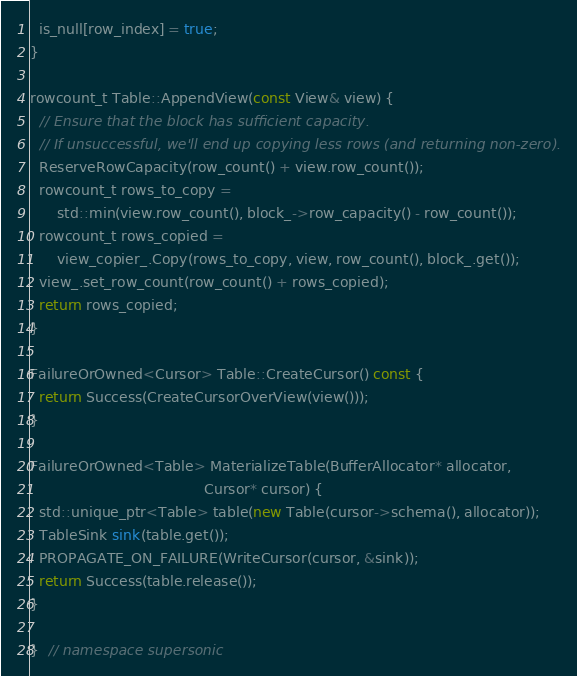<code> <loc_0><loc_0><loc_500><loc_500><_C++_>  is_null[row_index] = true;
}

rowcount_t Table::AppendView(const View& view) {
  // Ensure that the block has sufficient capacity.
  // If unsuccessful, we'll end up copying less rows (and returning non-zero).
  ReserveRowCapacity(row_count() + view.row_count());
  rowcount_t rows_to_copy =
      std::min(view.row_count(), block_->row_capacity() - row_count());
  rowcount_t rows_copied =
      view_copier_.Copy(rows_to_copy, view, row_count(), block_.get());
  view_.set_row_count(row_count() + rows_copied);
  return rows_copied;
}

FailureOrOwned<Cursor> Table::CreateCursor() const {
  return Success(CreateCursorOverView(view()));
}

FailureOrOwned<Table> MaterializeTable(BufferAllocator* allocator,
                                       Cursor* cursor) {
  std::unique_ptr<Table> table(new Table(cursor->schema(), allocator));
  TableSink sink(table.get());
  PROPAGATE_ON_FAILURE(WriteCursor(cursor, &sink));
  return Success(table.release());
}

}  // namespace supersonic
</code> 